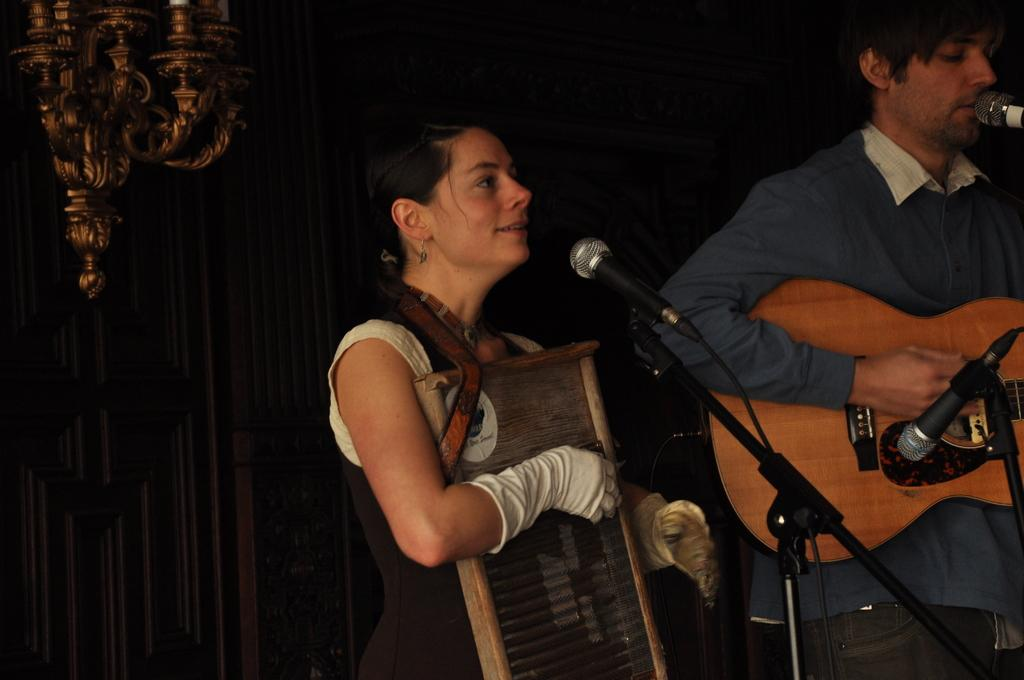How many people are in the image? There are two persons in the image. What are the two persons doing in the image? The two persons are singing and playing musical instruments. What object is placed in front of them? There is a microphone (mic) in front of them. Can you see a zebra playing a horn in the image? No, there is no zebra or horn present in the image. What type of beam is supporting the musical instruments in the image? There is no beam visible in the image; the focus is on the two persons and the microphone. 